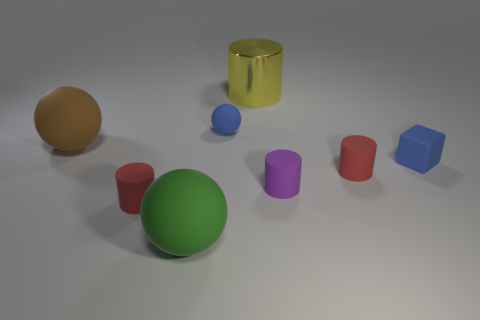Are there any objects that stand out in color or size compared to the others? The green ball stands out in size as it appears to be the largest object in the image. In terms of color, the yellow cylinder has a vibrant hue that makes it quite eye-catching against the more subdued colors of the surrounding objects. 